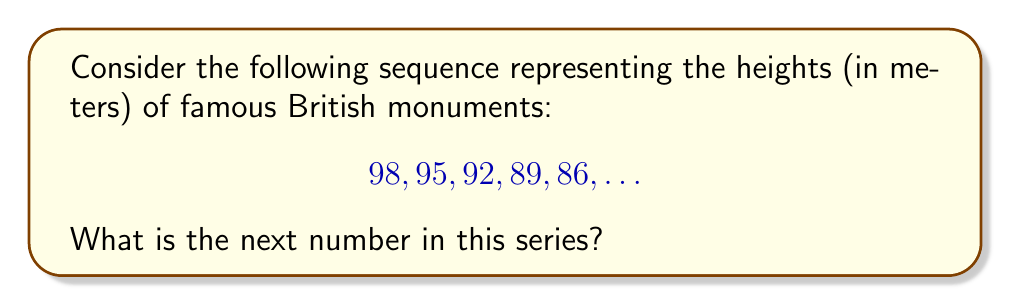Help me with this question. To solve this problem, let's approach it step-by-step:

1) First, we need to identify the pattern in the sequence. Let's look at the differences between consecutive terms:

   98 → 95 (difference: -3)
   95 → 92 (difference: -3)
   92 → 89 (difference: -3)
   89 → 86 (difference: -3)

2) We can see that the sequence is decreasing by 3 meters each time. This is an arithmetic sequence with a common difference of -3.

3) In mathematical terms, we can express this sequence as:

   $$a_n = a_1 + (n-1)d$$

   Where $a_n$ is the nth term, $a_1$ is the first term, $n$ is the position of the term, and $d$ is the common difference.

4) In this case:
   $a_1 = 98$ (first term)
   $d = -3$ (common difference)

5) We're looking for the 6th term in the sequence, so $n = 6$

6) Plugging these values into our formula:

   $$a_6 = 98 + (6-1)(-3)$$
   $$a_6 = 98 + (-15)$$
   $$a_6 = 83$$

Therefore, the next number in the sequence, representing the height of the next monument, would be 83 meters.
Answer: 83 